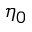<formula> <loc_0><loc_0><loc_500><loc_500>\eta _ { 0 }</formula> 